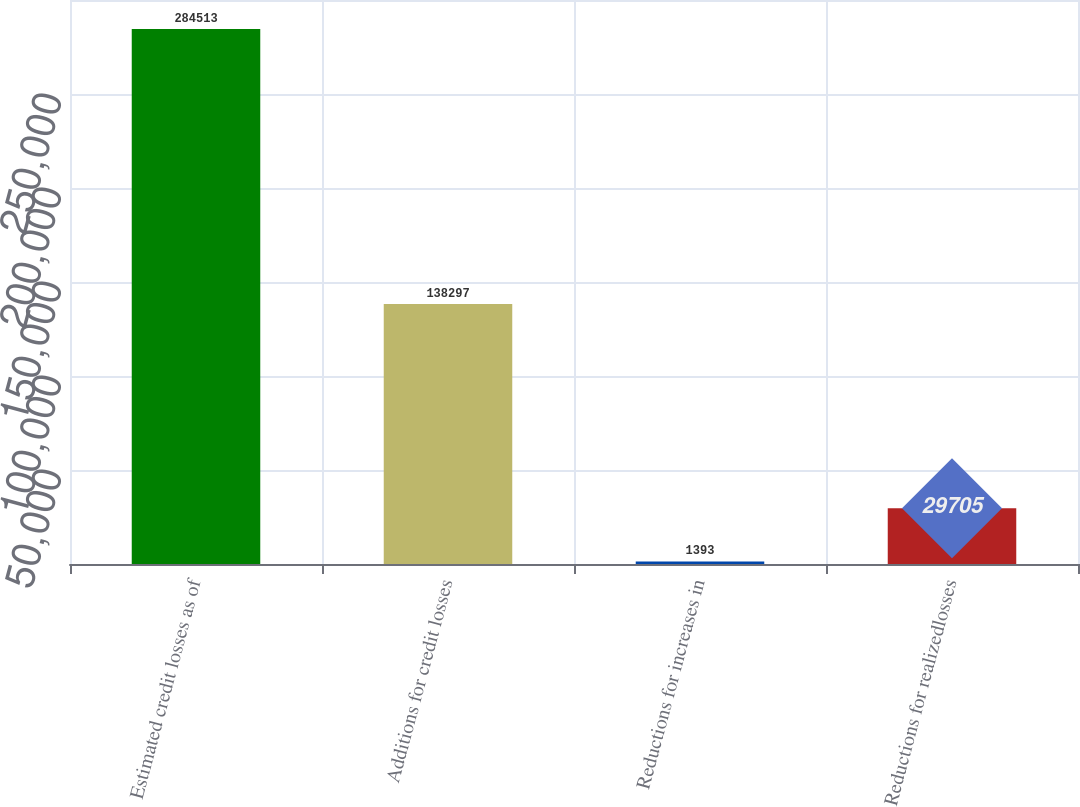Convert chart to OTSL. <chart><loc_0><loc_0><loc_500><loc_500><bar_chart><fcel>Estimated credit losses as of<fcel>Additions for credit losses<fcel>Reductions for increases in<fcel>Reductions for realizedlosses<nl><fcel>284513<fcel>138297<fcel>1393<fcel>29705<nl></chart> 